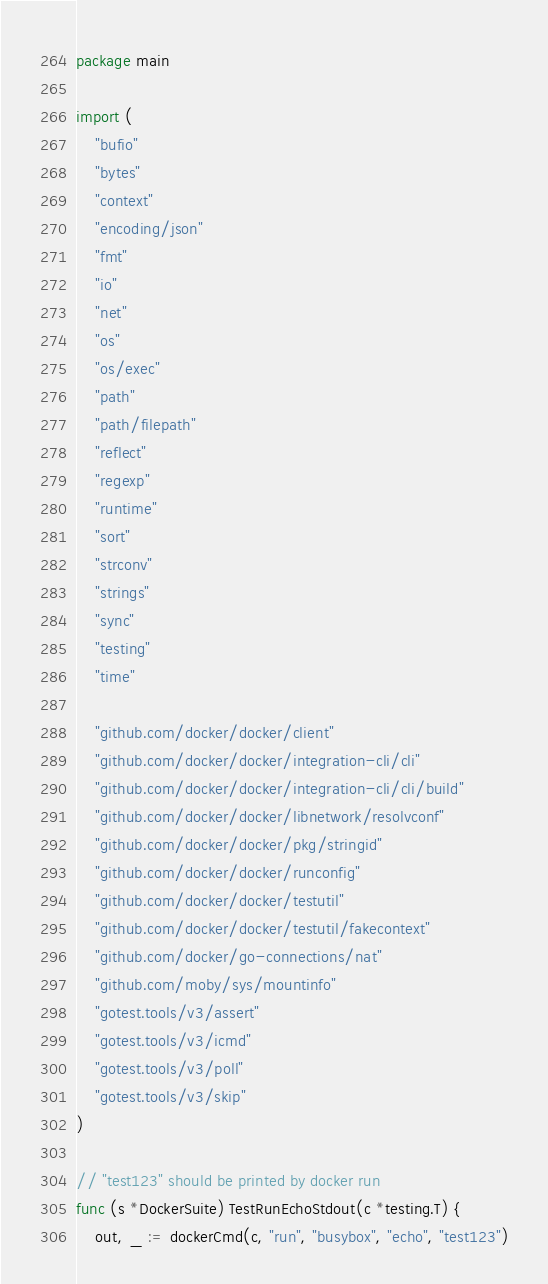<code> <loc_0><loc_0><loc_500><loc_500><_Go_>package main

import (
	"bufio"
	"bytes"
	"context"
	"encoding/json"
	"fmt"
	"io"
	"net"
	"os"
	"os/exec"
	"path"
	"path/filepath"
	"reflect"
	"regexp"
	"runtime"
	"sort"
	"strconv"
	"strings"
	"sync"
	"testing"
	"time"

	"github.com/docker/docker/client"
	"github.com/docker/docker/integration-cli/cli"
	"github.com/docker/docker/integration-cli/cli/build"
	"github.com/docker/docker/libnetwork/resolvconf"
	"github.com/docker/docker/pkg/stringid"
	"github.com/docker/docker/runconfig"
	"github.com/docker/docker/testutil"
	"github.com/docker/docker/testutil/fakecontext"
	"github.com/docker/go-connections/nat"
	"github.com/moby/sys/mountinfo"
	"gotest.tools/v3/assert"
	"gotest.tools/v3/icmd"
	"gotest.tools/v3/poll"
	"gotest.tools/v3/skip"
)

// "test123" should be printed by docker run
func (s *DockerSuite) TestRunEchoStdout(c *testing.T) {
	out, _ := dockerCmd(c, "run", "busybox", "echo", "test123")</code> 